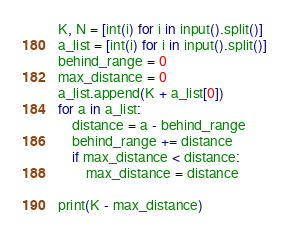<code> <loc_0><loc_0><loc_500><loc_500><_Python_>K, N = [int(i) for i in input().split()]
a_list = [int(i) for i in input().split()]
behind_range = 0
max_distance = 0
a_list.append(K + a_list[0])
for a in a_list:
    distance = a - behind_range
    behind_range += distance
    if max_distance < distance:
        max_distance = distance

print(K - max_distance)
</code> 